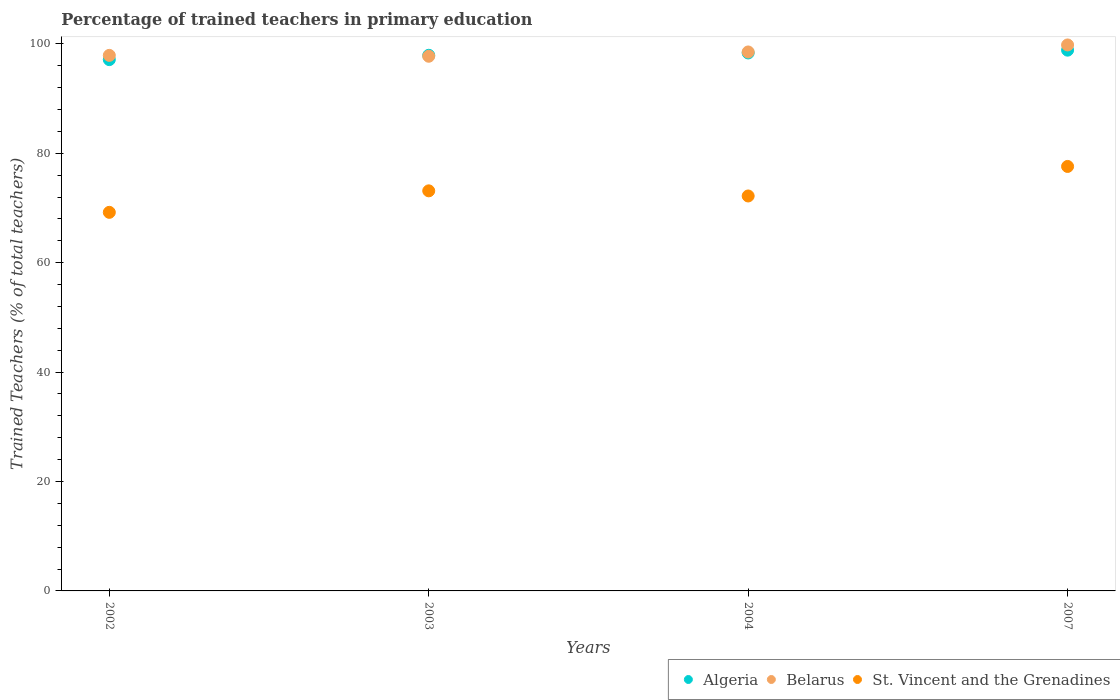Is the number of dotlines equal to the number of legend labels?
Provide a short and direct response. Yes. What is the percentage of trained teachers in St. Vincent and the Grenadines in 2003?
Ensure brevity in your answer.  73.14. Across all years, what is the maximum percentage of trained teachers in Algeria?
Give a very brief answer. 98.86. Across all years, what is the minimum percentage of trained teachers in Algeria?
Provide a short and direct response. 97.13. What is the total percentage of trained teachers in St. Vincent and the Grenadines in the graph?
Ensure brevity in your answer.  292.15. What is the difference between the percentage of trained teachers in Belarus in 2004 and that in 2007?
Keep it short and to the point. -1.28. What is the difference between the percentage of trained teachers in Belarus in 2004 and the percentage of trained teachers in St. Vincent and the Grenadines in 2007?
Give a very brief answer. 20.93. What is the average percentage of trained teachers in Belarus per year?
Give a very brief answer. 98.5. In the year 2007, what is the difference between the percentage of trained teachers in Belarus and percentage of trained teachers in St. Vincent and the Grenadines?
Your answer should be very brief. 22.21. In how many years, is the percentage of trained teachers in Belarus greater than 52 %?
Your answer should be very brief. 4. What is the ratio of the percentage of trained teachers in Algeria in 2003 to that in 2004?
Your answer should be very brief. 1. Is the percentage of trained teachers in St. Vincent and the Grenadines in 2002 less than that in 2004?
Offer a very short reply. Yes. Is the difference between the percentage of trained teachers in Belarus in 2002 and 2003 greater than the difference between the percentage of trained teachers in St. Vincent and the Grenadines in 2002 and 2003?
Your answer should be very brief. Yes. What is the difference between the highest and the second highest percentage of trained teachers in Algeria?
Offer a terse response. 0.51. What is the difference between the highest and the lowest percentage of trained teachers in Algeria?
Your answer should be very brief. 1.73. Is the sum of the percentage of trained teachers in Algeria in 2002 and 2004 greater than the maximum percentage of trained teachers in Belarus across all years?
Make the answer very short. Yes. Is it the case that in every year, the sum of the percentage of trained teachers in Belarus and percentage of trained teachers in St. Vincent and the Grenadines  is greater than the percentage of trained teachers in Algeria?
Make the answer very short. Yes. Is the percentage of trained teachers in Algeria strictly greater than the percentage of trained teachers in Belarus over the years?
Provide a short and direct response. No. How many dotlines are there?
Make the answer very short. 3. Does the graph contain any zero values?
Provide a succinct answer. No. Where does the legend appear in the graph?
Your answer should be compact. Bottom right. How many legend labels are there?
Offer a very short reply. 3. What is the title of the graph?
Make the answer very short. Percentage of trained teachers in primary education. Does "Israel" appear as one of the legend labels in the graph?
Offer a terse response. No. What is the label or title of the X-axis?
Keep it short and to the point. Years. What is the label or title of the Y-axis?
Make the answer very short. Trained Teachers (% of total teachers). What is the Trained Teachers (% of total teachers) in Algeria in 2002?
Provide a short and direct response. 97.13. What is the Trained Teachers (% of total teachers) of Belarus in 2002?
Your answer should be very brief. 97.9. What is the Trained Teachers (% of total teachers) of St. Vincent and the Grenadines in 2002?
Keep it short and to the point. 69.21. What is the Trained Teachers (% of total teachers) in Algeria in 2003?
Provide a short and direct response. 97.92. What is the Trained Teachers (% of total teachers) in Belarus in 2003?
Keep it short and to the point. 97.74. What is the Trained Teachers (% of total teachers) in St. Vincent and the Grenadines in 2003?
Ensure brevity in your answer.  73.14. What is the Trained Teachers (% of total teachers) in Algeria in 2004?
Your answer should be compact. 98.35. What is the Trained Teachers (% of total teachers) of Belarus in 2004?
Give a very brief answer. 98.53. What is the Trained Teachers (% of total teachers) in St. Vincent and the Grenadines in 2004?
Make the answer very short. 72.2. What is the Trained Teachers (% of total teachers) of Algeria in 2007?
Keep it short and to the point. 98.86. What is the Trained Teachers (% of total teachers) in Belarus in 2007?
Your answer should be very brief. 99.81. What is the Trained Teachers (% of total teachers) of St. Vincent and the Grenadines in 2007?
Provide a short and direct response. 77.6. Across all years, what is the maximum Trained Teachers (% of total teachers) of Algeria?
Keep it short and to the point. 98.86. Across all years, what is the maximum Trained Teachers (% of total teachers) in Belarus?
Provide a succinct answer. 99.81. Across all years, what is the maximum Trained Teachers (% of total teachers) in St. Vincent and the Grenadines?
Ensure brevity in your answer.  77.6. Across all years, what is the minimum Trained Teachers (% of total teachers) in Algeria?
Ensure brevity in your answer.  97.13. Across all years, what is the minimum Trained Teachers (% of total teachers) in Belarus?
Your response must be concise. 97.74. Across all years, what is the minimum Trained Teachers (% of total teachers) in St. Vincent and the Grenadines?
Make the answer very short. 69.21. What is the total Trained Teachers (% of total teachers) of Algeria in the graph?
Ensure brevity in your answer.  392.25. What is the total Trained Teachers (% of total teachers) in Belarus in the graph?
Your answer should be compact. 393.98. What is the total Trained Teachers (% of total teachers) in St. Vincent and the Grenadines in the graph?
Offer a terse response. 292.15. What is the difference between the Trained Teachers (% of total teachers) of Algeria in 2002 and that in 2003?
Offer a terse response. -0.79. What is the difference between the Trained Teachers (% of total teachers) in Belarus in 2002 and that in 2003?
Give a very brief answer. 0.16. What is the difference between the Trained Teachers (% of total teachers) of St. Vincent and the Grenadines in 2002 and that in 2003?
Offer a terse response. -3.93. What is the difference between the Trained Teachers (% of total teachers) of Algeria in 2002 and that in 2004?
Ensure brevity in your answer.  -1.22. What is the difference between the Trained Teachers (% of total teachers) in Belarus in 2002 and that in 2004?
Your answer should be very brief. -0.62. What is the difference between the Trained Teachers (% of total teachers) of St. Vincent and the Grenadines in 2002 and that in 2004?
Ensure brevity in your answer.  -2.99. What is the difference between the Trained Teachers (% of total teachers) of Algeria in 2002 and that in 2007?
Make the answer very short. -1.73. What is the difference between the Trained Teachers (% of total teachers) in Belarus in 2002 and that in 2007?
Your answer should be compact. -1.91. What is the difference between the Trained Teachers (% of total teachers) in St. Vincent and the Grenadines in 2002 and that in 2007?
Your response must be concise. -8.39. What is the difference between the Trained Teachers (% of total teachers) of Algeria in 2003 and that in 2004?
Your answer should be very brief. -0.43. What is the difference between the Trained Teachers (% of total teachers) of Belarus in 2003 and that in 2004?
Give a very brief answer. -0.79. What is the difference between the Trained Teachers (% of total teachers) of St. Vincent and the Grenadines in 2003 and that in 2004?
Your answer should be very brief. 0.94. What is the difference between the Trained Teachers (% of total teachers) of Algeria in 2003 and that in 2007?
Keep it short and to the point. -0.94. What is the difference between the Trained Teachers (% of total teachers) in Belarus in 2003 and that in 2007?
Ensure brevity in your answer.  -2.07. What is the difference between the Trained Teachers (% of total teachers) of St. Vincent and the Grenadines in 2003 and that in 2007?
Give a very brief answer. -4.46. What is the difference between the Trained Teachers (% of total teachers) in Algeria in 2004 and that in 2007?
Give a very brief answer. -0.51. What is the difference between the Trained Teachers (% of total teachers) in Belarus in 2004 and that in 2007?
Provide a short and direct response. -1.28. What is the difference between the Trained Teachers (% of total teachers) in St. Vincent and the Grenadines in 2004 and that in 2007?
Provide a short and direct response. -5.4. What is the difference between the Trained Teachers (% of total teachers) of Algeria in 2002 and the Trained Teachers (% of total teachers) of Belarus in 2003?
Your response must be concise. -0.62. What is the difference between the Trained Teachers (% of total teachers) of Algeria in 2002 and the Trained Teachers (% of total teachers) of St. Vincent and the Grenadines in 2003?
Provide a succinct answer. 23.99. What is the difference between the Trained Teachers (% of total teachers) in Belarus in 2002 and the Trained Teachers (% of total teachers) in St. Vincent and the Grenadines in 2003?
Ensure brevity in your answer.  24.77. What is the difference between the Trained Teachers (% of total teachers) of Algeria in 2002 and the Trained Teachers (% of total teachers) of Belarus in 2004?
Provide a short and direct response. -1.4. What is the difference between the Trained Teachers (% of total teachers) in Algeria in 2002 and the Trained Teachers (% of total teachers) in St. Vincent and the Grenadines in 2004?
Provide a succinct answer. 24.93. What is the difference between the Trained Teachers (% of total teachers) of Belarus in 2002 and the Trained Teachers (% of total teachers) of St. Vincent and the Grenadines in 2004?
Offer a terse response. 25.7. What is the difference between the Trained Teachers (% of total teachers) of Algeria in 2002 and the Trained Teachers (% of total teachers) of Belarus in 2007?
Ensure brevity in your answer.  -2.68. What is the difference between the Trained Teachers (% of total teachers) of Algeria in 2002 and the Trained Teachers (% of total teachers) of St. Vincent and the Grenadines in 2007?
Offer a very short reply. 19.53. What is the difference between the Trained Teachers (% of total teachers) of Belarus in 2002 and the Trained Teachers (% of total teachers) of St. Vincent and the Grenadines in 2007?
Offer a very short reply. 20.3. What is the difference between the Trained Teachers (% of total teachers) of Algeria in 2003 and the Trained Teachers (% of total teachers) of Belarus in 2004?
Make the answer very short. -0.61. What is the difference between the Trained Teachers (% of total teachers) of Algeria in 2003 and the Trained Teachers (% of total teachers) of St. Vincent and the Grenadines in 2004?
Provide a succinct answer. 25.72. What is the difference between the Trained Teachers (% of total teachers) in Belarus in 2003 and the Trained Teachers (% of total teachers) in St. Vincent and the Grenadines in 2004?
Offer a terse response. 25.54. What is the difference between the Trained Teachers (% of total teachers) in Algeria in 2003 and the Trained Teachers (% of total teachers) in Belarus in 2007?
Provide a short and direct response. -1.89. What is the difference between the Trained Teachers (% of total teachers) in Algeria in 2003 and the Trained Teachers (% of total teachers) in St. Vincent and the Grenadines in 2007?
Offer a terse response. 20.32. What is the difference between the Trained Teachers (% of total teachers) in Belarus in 2003 and the Trained Teachers (% of total teachers) in St. Vincent and the Grenadines in 2007?
Offer a terse response. 20.14. What is the difference between the Trained Teachers (% of total teachers) in Algeria in 2004 and the Trained Teachers (% of total teachers) in Belarus in 2007?
Offer a terse response. -1.46. What is the difference between the Trained Teachers (% of total teachers) in Algeria in 2004 and the Trained Teachers (% of total teachers) in St. Vincent and the Grenadines in 2007?
Provide a succinct answer. 20.75. What is the difference between the Trained Teachers (% of total teachers) of Belarus in 2004 and the Trained Teachers (% of total teachers) of St. Vincent and the Grenadines in 2007?
Your response must be concise. 20.93. What is the average Trained Teachers (% of total teachers) of Algeria per year?
Offer a very short reply. 98.06. What is the average Trained Teachers (% of total teachers) in Belarus per year?
Provide a succinct answer. 98.5. What is the average Trained Teachers (% of total teachers) in St. Vincent and the Grenadines per year?
Your answer should be compact. 73.04. In the year 2002, what is the difference between the Trained Teachers (% of total teachers) of Algeria and Trained Teachers (% of total teachers) of Belarus?
Provide a short and direct response. -0.78. In the year 2002, what is the difference between the Trained Teachers (% of total teachers) of Algeria and Trained Teachers (% of total teachers) of St. Vincent and the Grenadines?
Your response must be concise. 27.92. In the year 2002, what is the difference between the Trained Teachers (% of total teachers) in Belarus and Trained Teachers (% of total teachers) in St. Vincent and the Grenadines?
Give a very brief answer. 28.7. In the year 2003, what is the difference between the Trained Teachers (% of total teachers) of Algeria and Trained Teachers (% of total teachers) of Belarus?
Make the answer very short. 0.18. In the year 2003, what is the difference between the Trained Teachers (% of total teachers) of Algeria and Trained Teachers (% of total teachers) of St. Vincent and the Grenadines?
Your answer should be very brief. 24.78. In the year 2003, what is the difference between the Trained Teachers (% of total teachers) of Belarus and Trained Teachers (% of total teachers) of St. Vincent and the Grenadines?
Keep it short and to the point. 24.6. In the year 2004, what is the difference between the Trained Teachers (% of total teachers) in Algeria and Trained Teachers (% of total teachers) in Belarus?
Offer a very short reply. -0.18. In the year 2004, what is the difference between the Trained Teachers (% of total teachers) of Algeria and Trained Teachers (% of total teachers) of St. Vincent and the Grenadines?
Keep it short and to the point. 26.15. In the year 2004, what is the difference between the Trained Teachers (% of total teachers) in Belarus and Trained Teachers (% of total teachers) in St. Vincent and the Grenadines?
Provide a short and direct response. 26.33. In the year 2007, what is the difference between the Trained Teachers (% of total teachers) of Algeria and Trained Teachers (% of total teachers) of Belarus?
Keep it short and to the point. -0.95. In the year 2007, what is the difference between the Trained Teachers (% of total teachers) in Algeria and Trained Teachers (% of total teachers) in St. Vincent and the Grenadines?
Make the answer very short. 21.26. In the year 2007, what is the difference between the Trained Teachers (% of total teachers) in Belarus and Trained Teachers (% of total teachers) in St. Vincent and the Grenadines?
Your answer should be compact. 22.21. What is the ratio of the Trained Teachers (% of total teachers) of Algeria in 2002 to that in 2003?
Provide a succinct answer. 0.99. What is the ratio of the Trained Teachers (% of total teachers) of Belarus in 2002 to that in 2003?
Your response must be concise. 1. What is the ratio of the Trained Teachers (% of total teachers) in St. Vincent and the Grenadines in 2002 to that in 2003?
Your answer should be very brief. 0.95. What is the ratio of the Trained Teachers (% of total teachers) of Algeria in 2002 to that in 2004?
Give a very brief answer. 0.99. What is the ratio of the Trained Teachers (% of total teachers) in St. Vincent and the Grenadines in 2002 to that in 2004?
Provide a short and direct response. 0.96. What is the ratio of the Trained Teachers (% of total teachers) in Algeria in 2002 to that in 2007?
Provide a succinct answer. 0.98. What is the ratio of the Trained Teachers (% of total teachers) in Belarus in 2002 to that in 2007?
Your answer should be compact. 0.98. What is the ratio of the Trained Teachers (% of total teachers) of St. Vincent and the Grenadines in 2002 to that in 2007?
Provide a short and direct response. 0.89. What is the ratio of the Trained Teachers (% of total teachers) in Algeria in 2003 to that in 2004?
Your answer should be very brief. 1. What is the ratio of the Trained Teachers (% of total teachers) of Belarus in 2003 to that in 2004?
Provide a succinct answer. 0.99. What is the ratio of the Trained Teachers (% of total teachers) of Belarus in 2003 to that in 2007?
Your answer should be very brief. 0.98. What is the ratio of the Trained Teachers (% of total teachers) of St. Vincent and the Grenadines in 2003 to that in 2007?
Offer a terse response. 0.94. What is the ratio of the Trained Teachers (% of total teachers) of Belarus in 2004 to that in 2007?
Ensure brevity in your answer.  0.99. What is the ratio of the Trained Teachers (% of total teachers) of St. Vincent and the Grenadines in 2004 to that in 2007?
Ensure brevity in your answer.  0.93. What is the difference between the highest and the second highest Trained Teachers (% of total teachers) of Algeria?
Give a very brief answer. 0.51. What is the difference between the highest and the second highest Trained Teachers (% of total teachers) in Belarus?
Offer a very short reply. 1.28. What is the difference between the highest and the second highest Trained Teachers (% of total teachers) in St. Vincent and the Grenadines?
Your response must be concise. 4.46. What is the difference between the highest and the lowest Trained Teachers (% of total teachers) in Algeria?
Provide a short and direct response. 1.73. What is the difference between the highest and the lowest Trained Teachers (% of total teachers) in Belarus?
Give a very brief answer. 2.07. What is the difference between the highest and the lowest Trained Teachers (% of total teachers) of St. Vincent and the Grenadines?
Offer a very short reply. 8.39. 